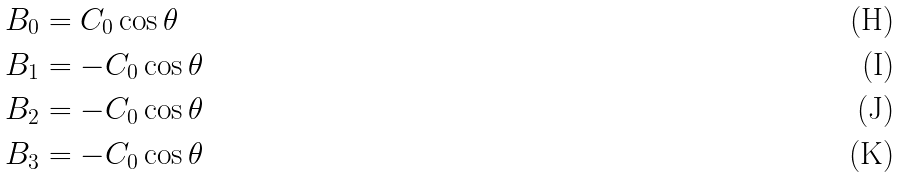Convert formula to latex. <formula><loc_0><loc_0><loc_500><loc_500>B _ { 0 } & = C _ { 0 } \cos \theta \\ B _ { 1 } & = - C _ { 0 } \cos \theta \\ B _ { 2 } & = - C _ { 0 } \cos \theta \\ B _ { 3 } & = - C _ { 0 } \cos \theta</formula> 